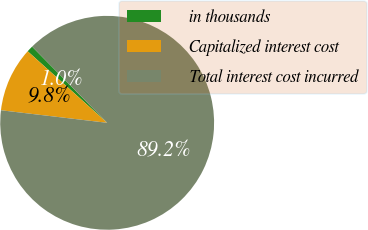Convert chart. <chart><loc_0><loc_0><loc_500><loc_500><pie_chart><fcel>in thousands<fcel>Capitalized interest cost<fcel>Total interest cost incurred<nl><fcel>0.96%<fcel>9.79%<fcel>89.25%<nl></chart> 